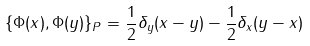<formula> <loc_0><loc_0><loc_500><loc_500>\{ \Phi ( x ) , \Phi ( y ) \} _ { P } = \frac { 1 } { 2 } \delta _ { y } ( x - y ) - \frac { 1 } { 2 } \delta _ { x } ( y - x )</formula> 